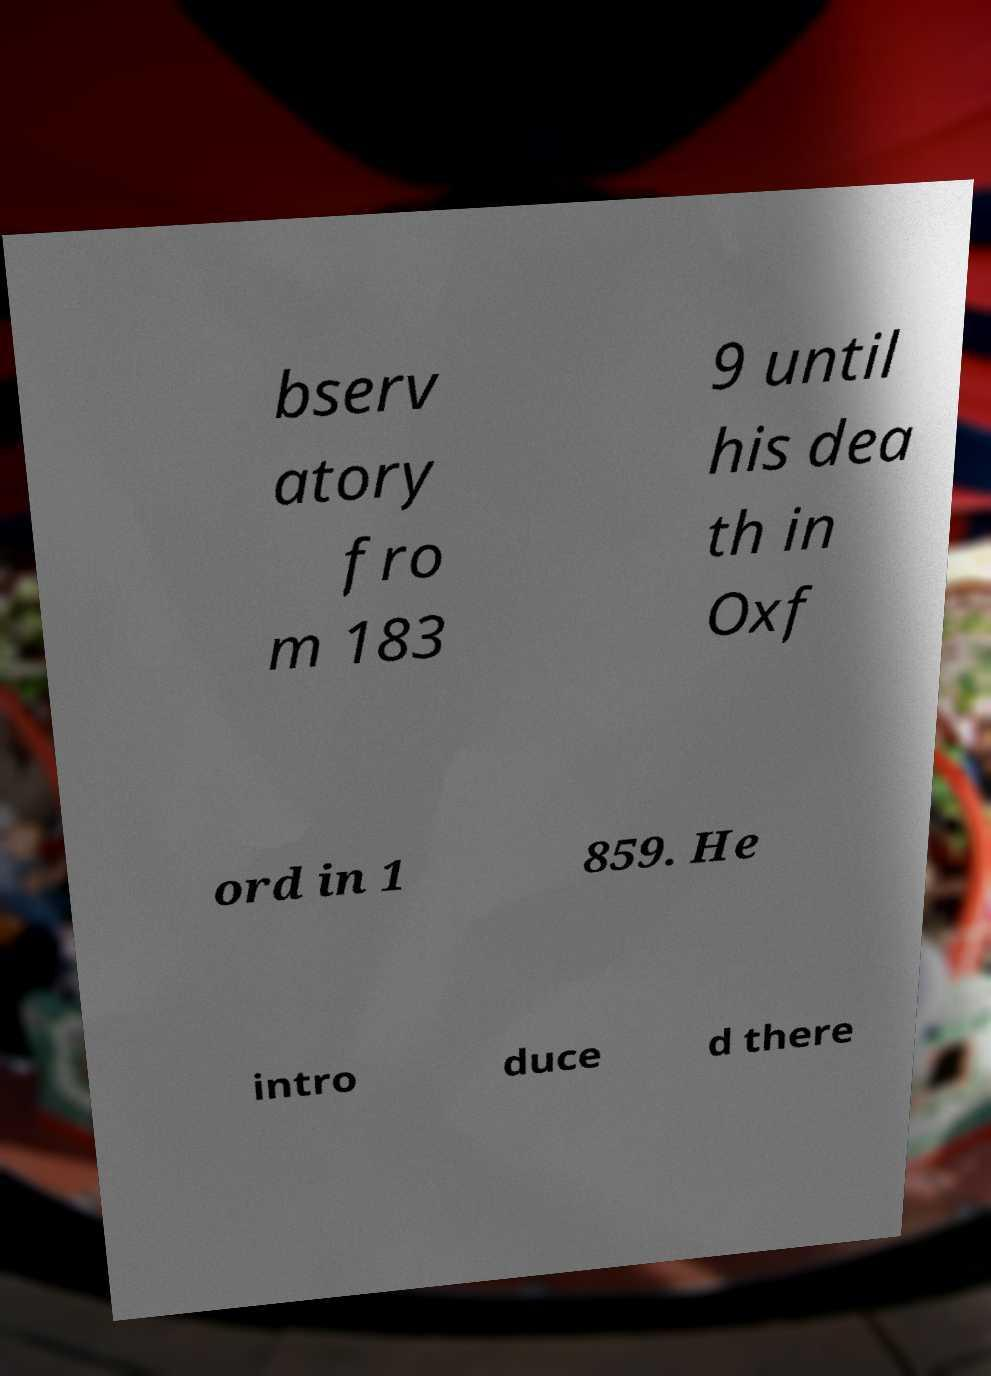What messages or text are displayed in this image? I need them in a readable, typed format. bserv atory fro m 183 9 until his dea th in Oxf ord in 1 859. He intro duce d there 